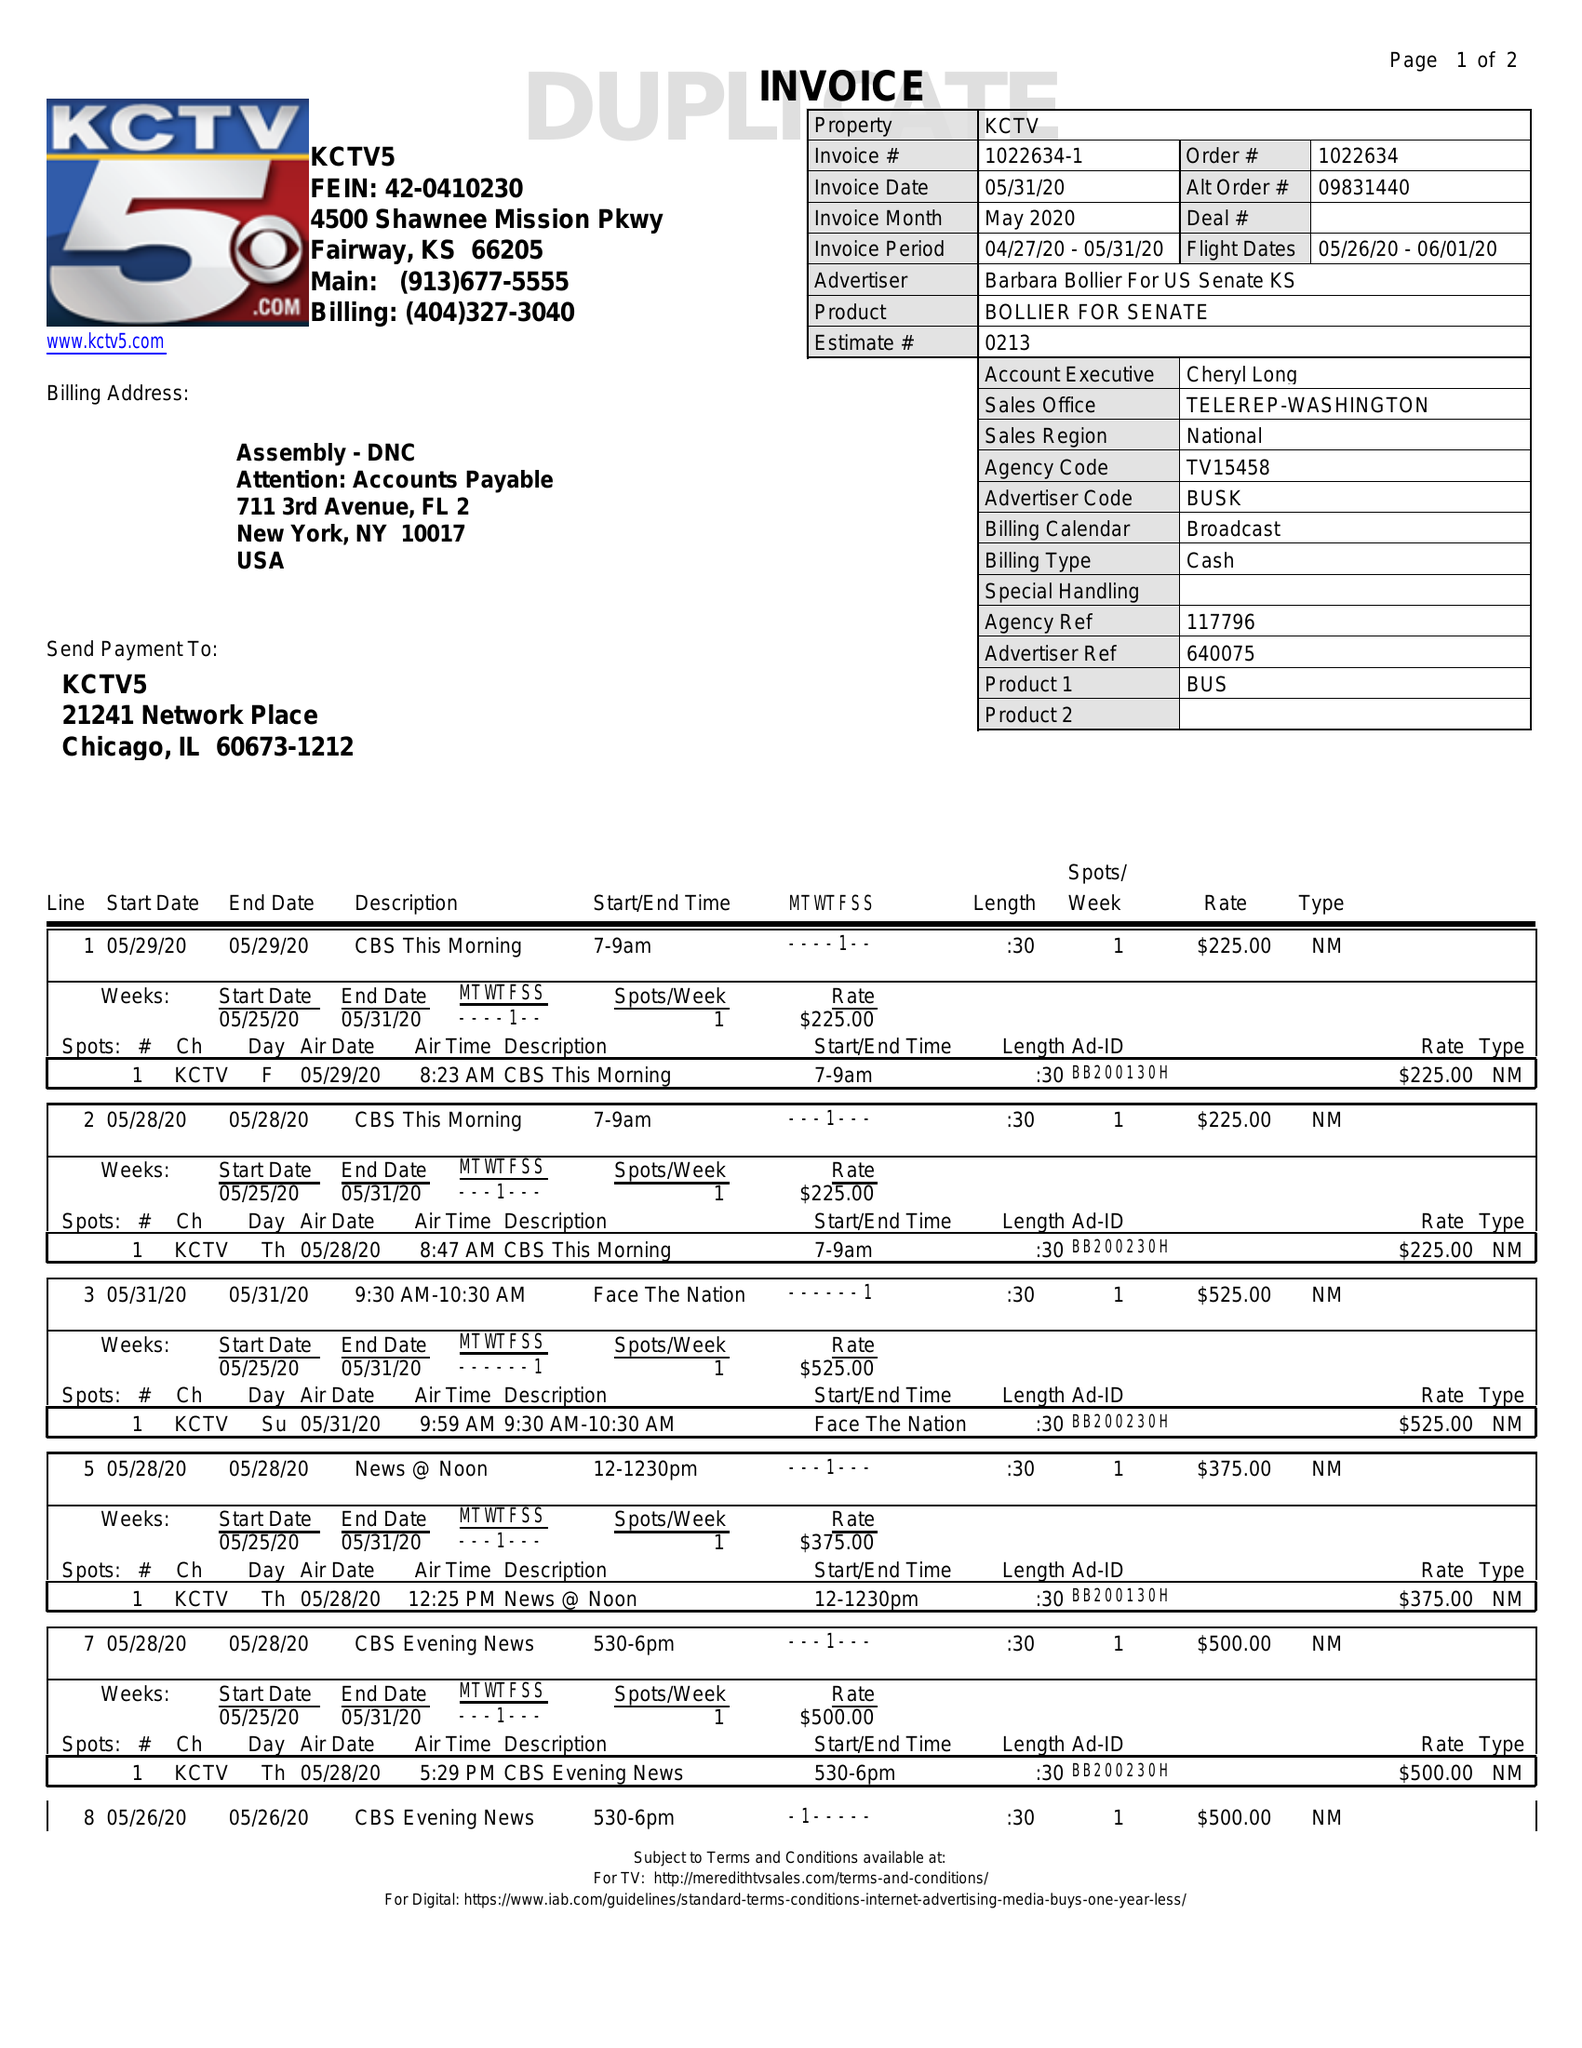What is the value for the advertiser?
Answer the question using a single word or phrase. BARBARA BOLLIER FOR US SENATE KS 